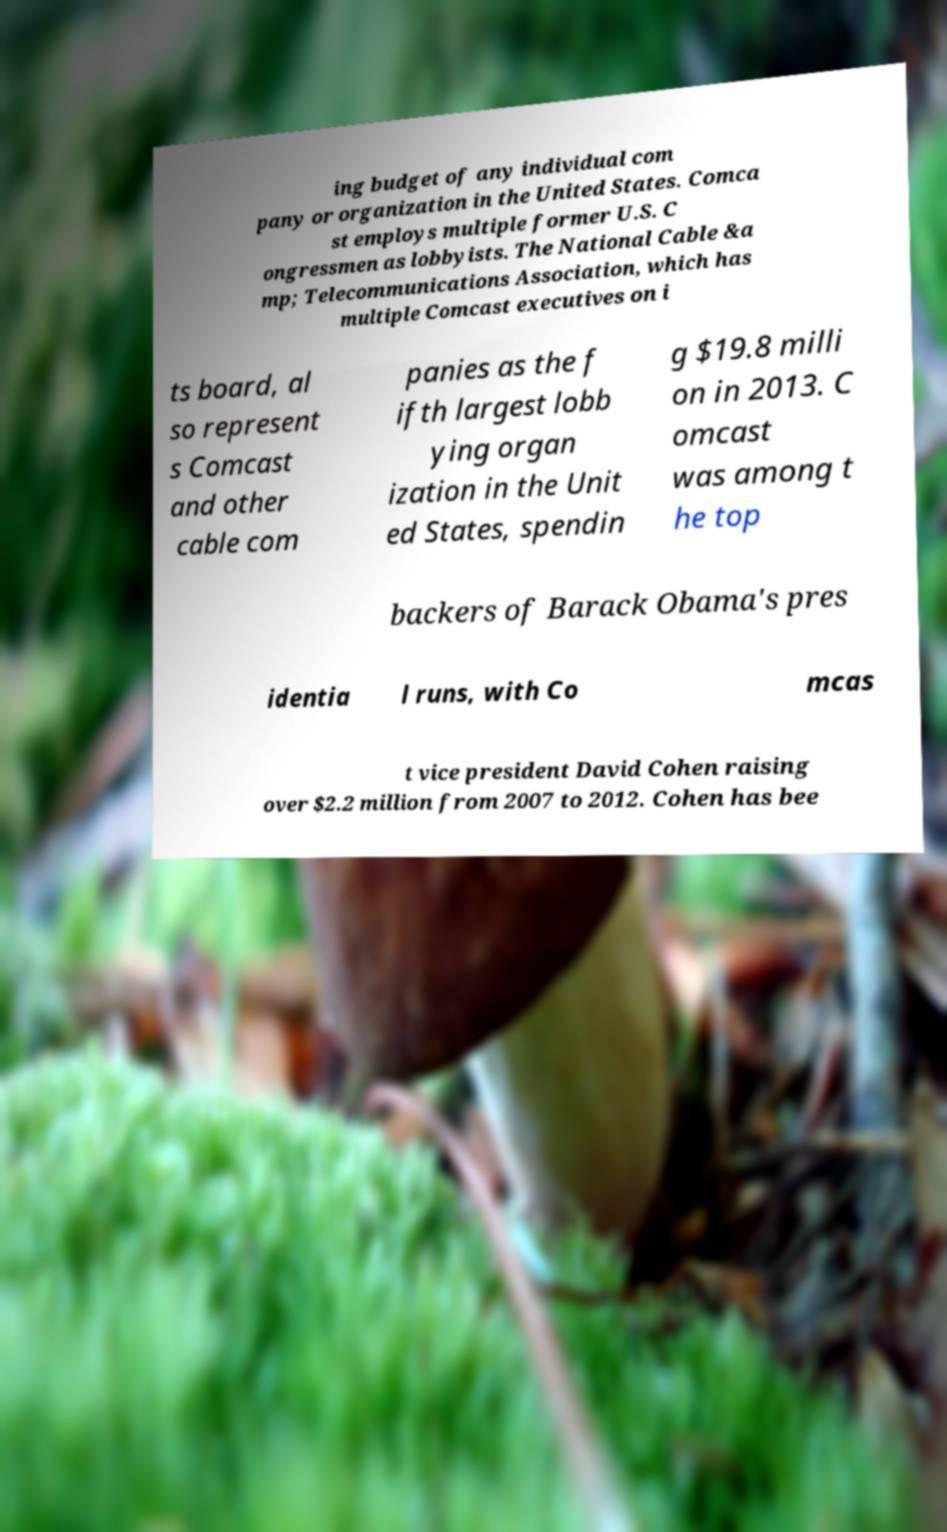Can you read and provide the text displayed in the image?This photo seems to have some interesting text. Can you extract and type it out for me? ing budget of any individual com pany or organization in the United States. Comca st employs multiple former U.S. C ongressmen as lobbyists. The National Cable &a mp; Telecommunications Association, which has multiple Comcast executives on i ts board, al so represent s Comcast and other cable com panies as the f ifth largest lobb ying organ ization in the Unit ed States, spendin g $19.8 milli on in 2013. C omcast was among t he top backers of Barack Obama's pres identia l runs, with Co mcas t vice president David Cohen raising over $2.2 million from 2007 to 2012. Cohen has bee 